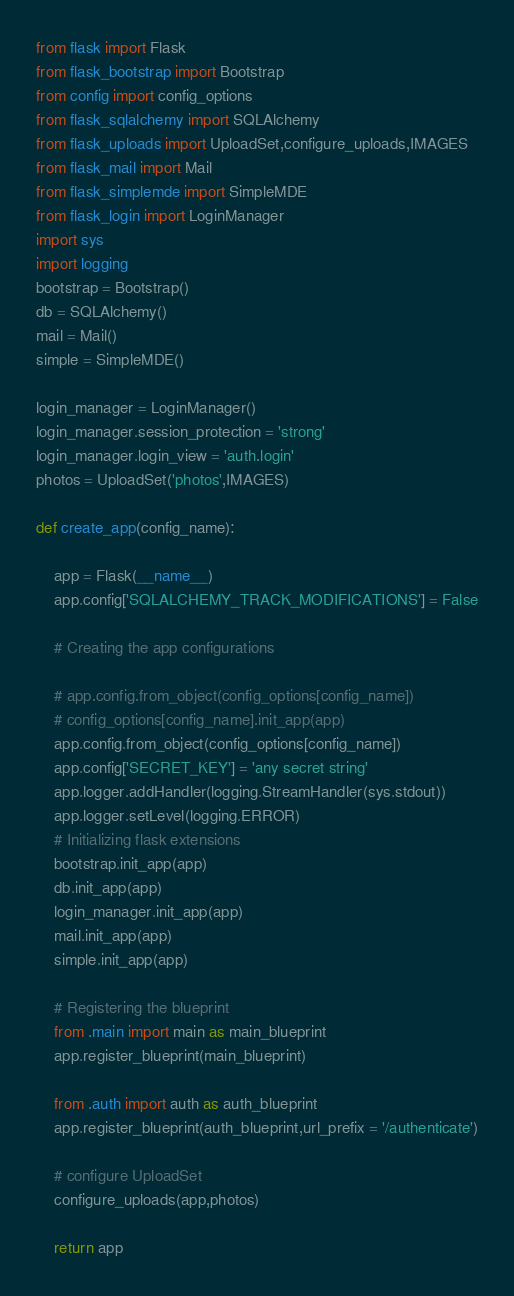Convert code to text. <code><loc_0><loc_0><loc_500><loc_500><_Python_>from flask import Flask
from flask_bootstrap import Bootstrap
from config import config_options
from flask_sqlalchemy import SQLAlchemy
from flask_uploads import UploadSet,configure_uploads,IMAGES
from flask_mail import Mail
from flask_simplemde import SimpleMDE
from flask_login import LoginManager
import sys
import logging
bootstrap = Bootstrap()
db = SQLAlchemy()
mail = Mail()
simple = SimpleMDE()

login_manager = LoginManager()
login_manager.session_protection = 'strong'
login_manager.login_view = 'auth.login'
photos = UploadSet('photos',IMAGES)

def create_app(config_name):

    app = Flask(__name__)
    app.config['SQLALCHEMY_TRACK_MODIFICATIONS'] = False

    # Creating the app configurations

    # app.config.from_object(config_options[config_name])
    # config_options[config_name].init_app(app)
    app.config.from_object(config_options[config_name])
    app.config['SECRET_KEY'] = 'any secret string'
    app.logger.addHandler(logging.StreamHandler(sys.stdout))
    app.logger.setLevel(logging.ERROR)
    # Initializing flask extensions
    bootstrap.init_app(app)
    db.init_app(app)
    login_manager.init_app(app)
    mail.init_app(app)
    simple.init_app(app)

    # Registering the blueprint
    from .main import main as main_blueprint
    app.register_blueprint(main_blueprint)

    from .auth import auth as auth_blueprint
    app.register_blueprint(auth_blueprint,url_prefix = '/authenticate')

    # configure UploadSet
    configure_uploads(app,photos)

    return app
</code> 